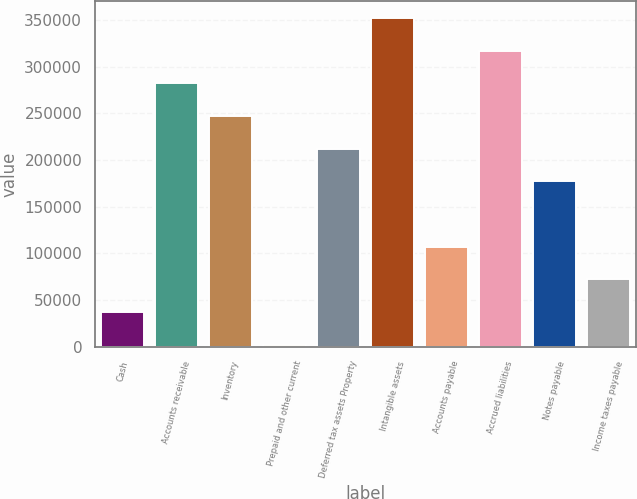Convert chart to OTSL. <chart><loc_0><loc_0><loc_500><loc_500><bar_chart><fcel>Cash<fcel>Accounts receivable<fcel>Inventory<fcel>Prepaid and other current<fcel>Deferred tax assets Property<fcel>Intangible assets<fcel>Accounts payable<fcel>Accrued liabilities<fcel>Notes payable<fcel>Income taxes payable<nl><fcel>36994.7<fcel>282154<fcel>247131<fcel>1972<fcel>212108<fcel>352199<fcel>107040<fcel>317176<fcel>177086<fcel>72017.4<nl></chart> 